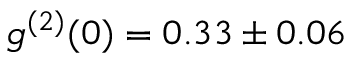Convert formula to latex. <formula><loc_0><loc_0><loc_500><loc_500>g ^ { ( 2 ) } ( 0 ) = 0 . 3 3 \pm 0 . 0 6</formula> 